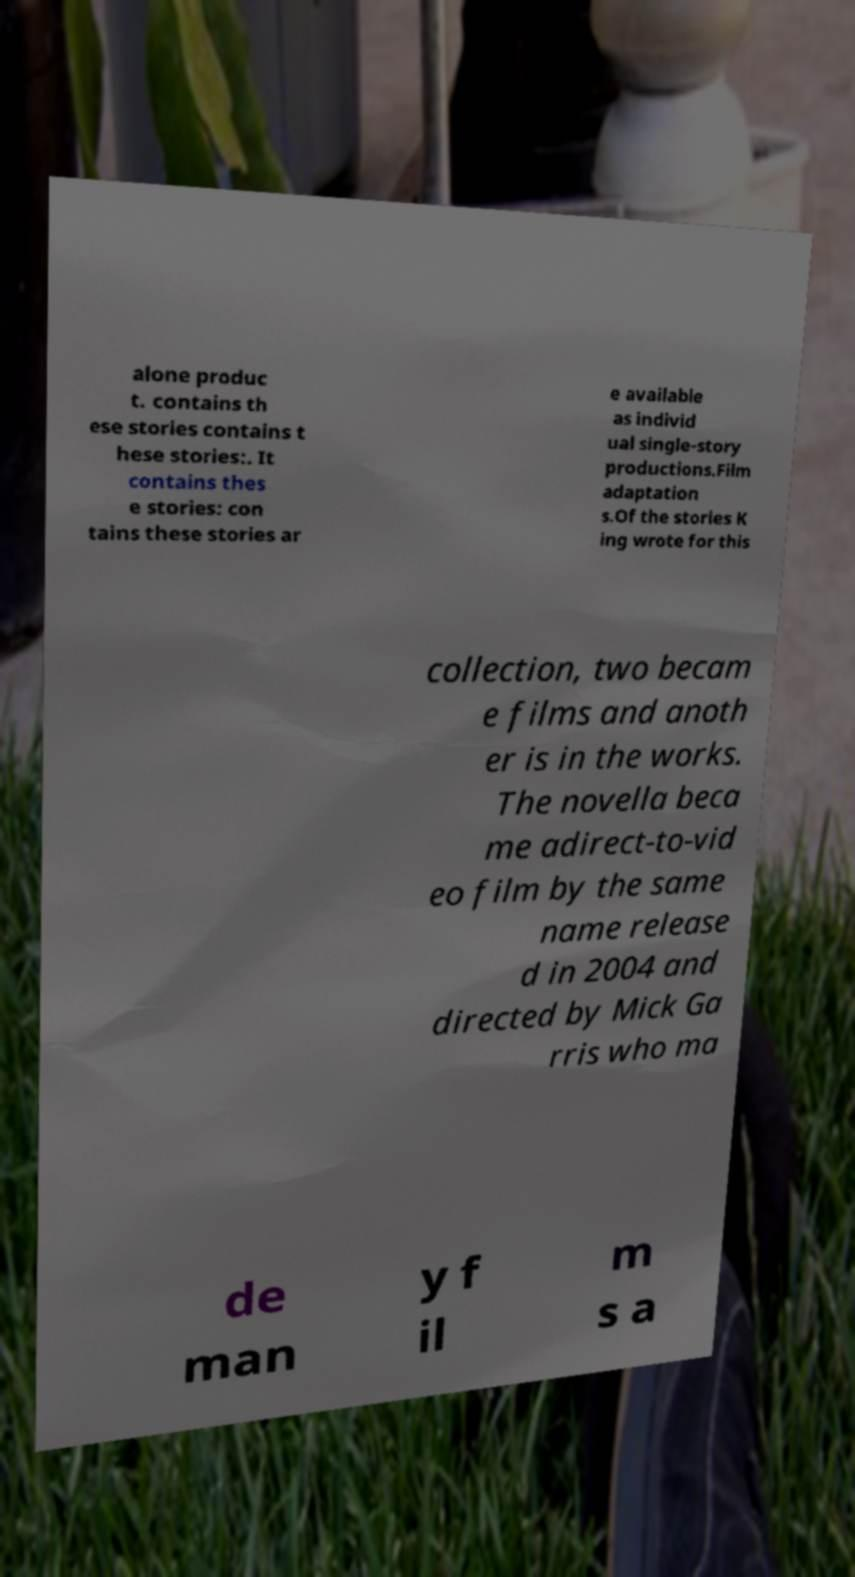Could you assist in decoding the text presented in this image and type it out clearly? alone produc t. contains th ese stories contains t hese stories:. It contains thes e stories: con tains these stories ar e available as individ ual single-story productions.Film adaptation s.Of the stories K ing wrote for this collection, two becam e films and anoth er is in the works. The novella beca me adirect-to-vid eo film by the same name release d in 2004 and directed by Mick Ga rris who ma de man y f il m s a 